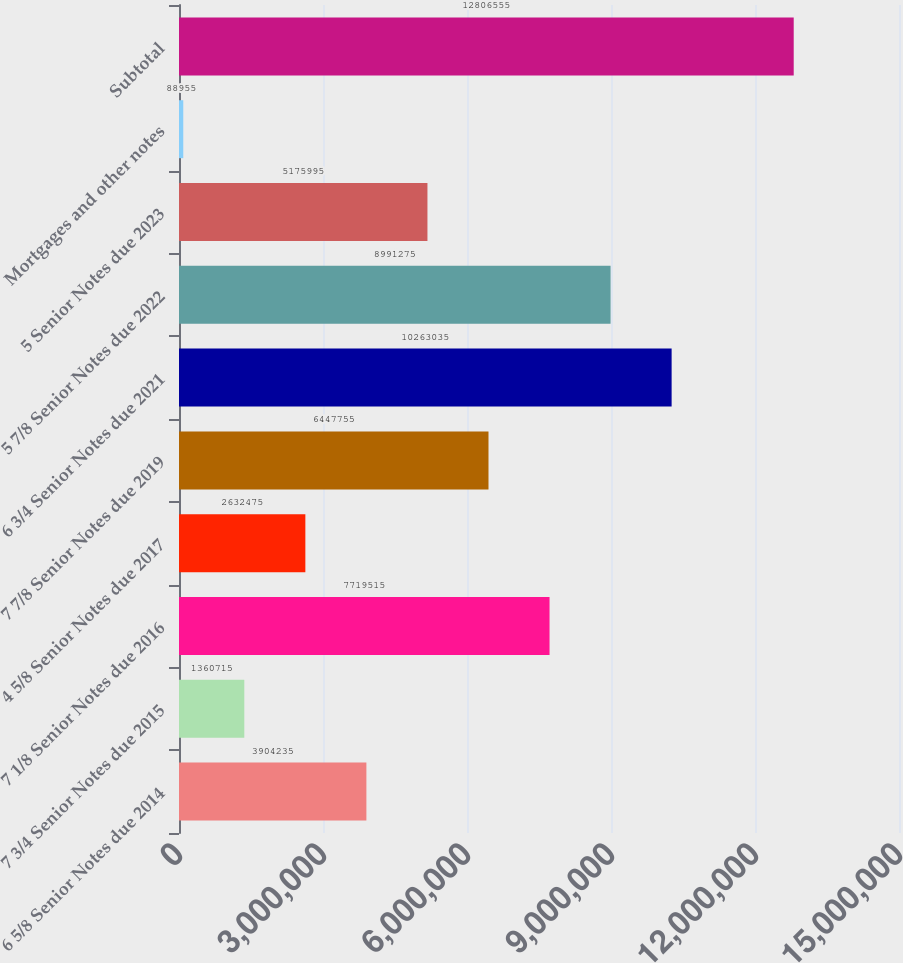Convert chart to OTSL. <chart><loc_0><loc_0><loc_500><loc_500><bar_chart><fcel>6 5/8 Senior Notes due 2014<fcel>7 3/4 Senior Notes due 2015<fcel>7 1/8 Senior Notes due 2016<fcel>4 5/8 Senior Notes due 2017<fcel>7 7/8 Senior Notes due 2019<fcel>6 3/4 Senior Notes due 2021<fcel>5 7/8 Senior Notes due 2022<fcel>5 Senior Notes due 2023<fcel>Mortgages and other notes<fcel>Subtotal<nl><fcel>3.90424e+06<fcel>1.36072e+06<fcel>7.71952e+06<fcel>2.63248e+06<fcel>6.44776e+06<fcel>1.0263e+07<fcel>8.99128e+06<fcel>5.176e+06<fcel>88955<fcel>1.28066e+07<nl></chart> 